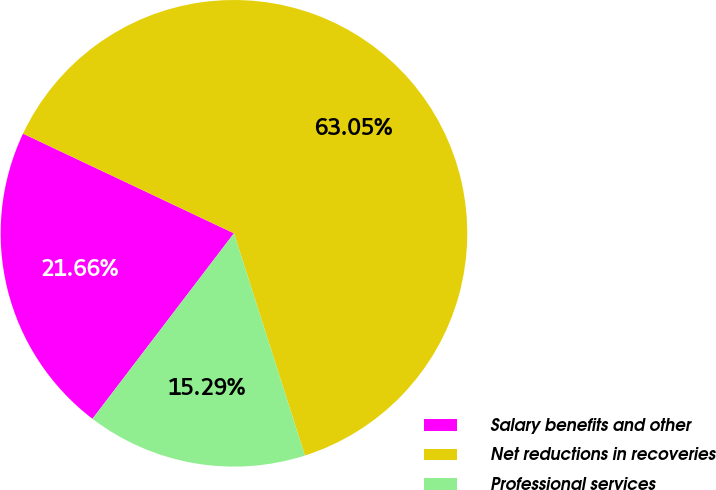Convert chart to OTSL. <chart><loc_0><loc_0><loc_500><loc_500><pie_chart><fcel>Salary benefits and other<fcel>Net reductions in recoveries<fcel>Professional services<nl><fcel>21.66%<fcel>63.06%<fcel>15.29%<nl></chart> 